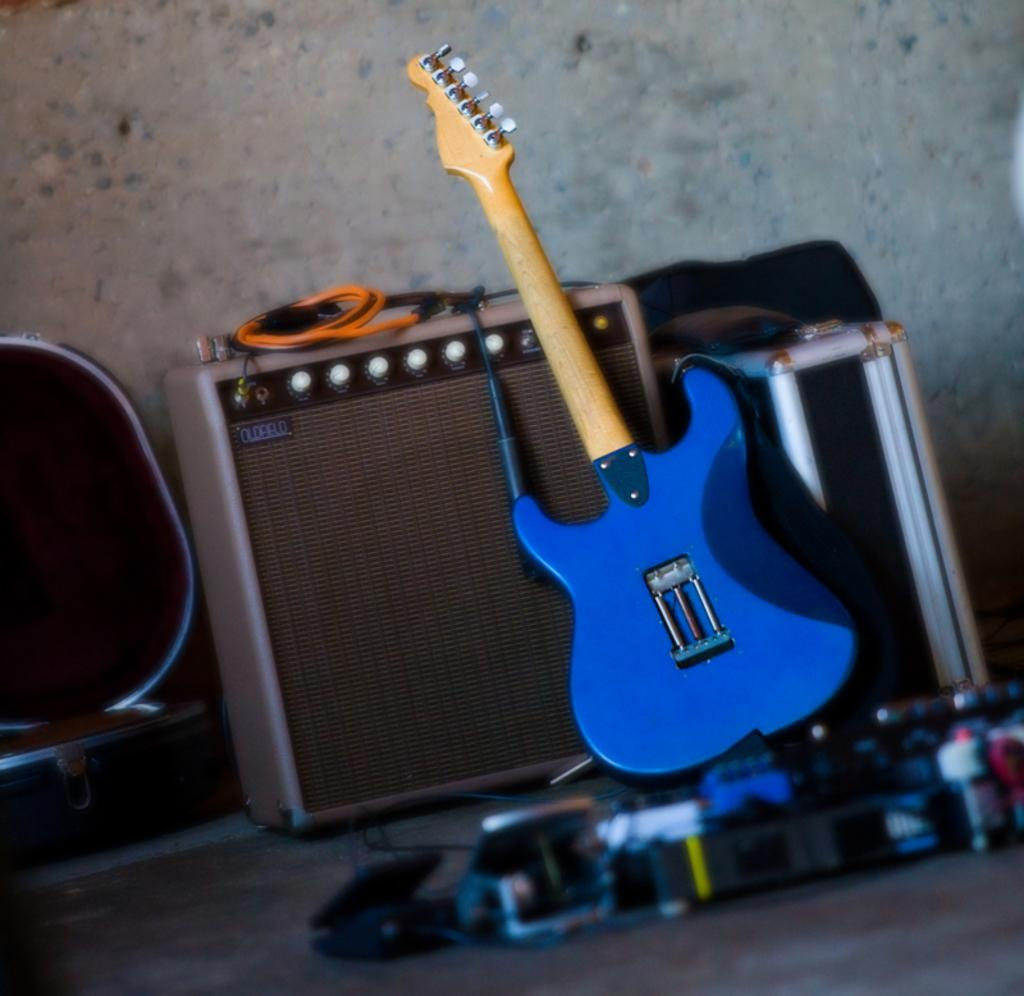What type of objects can be seen in the image? There are toys in the image, including a guitar and a speaker. Can you describe the unspecified object in the image? Unfortunately, the fact only mentions that there is an unspecified object in the image, so we cannot provide more details about it. What part of the room is visible in the image? The floor is visible at the bottom of the image, and there is a wall in the background. What type of bells can be heard ringing in the image? There are no bells present in the image, and therefore no sound can be heard. 